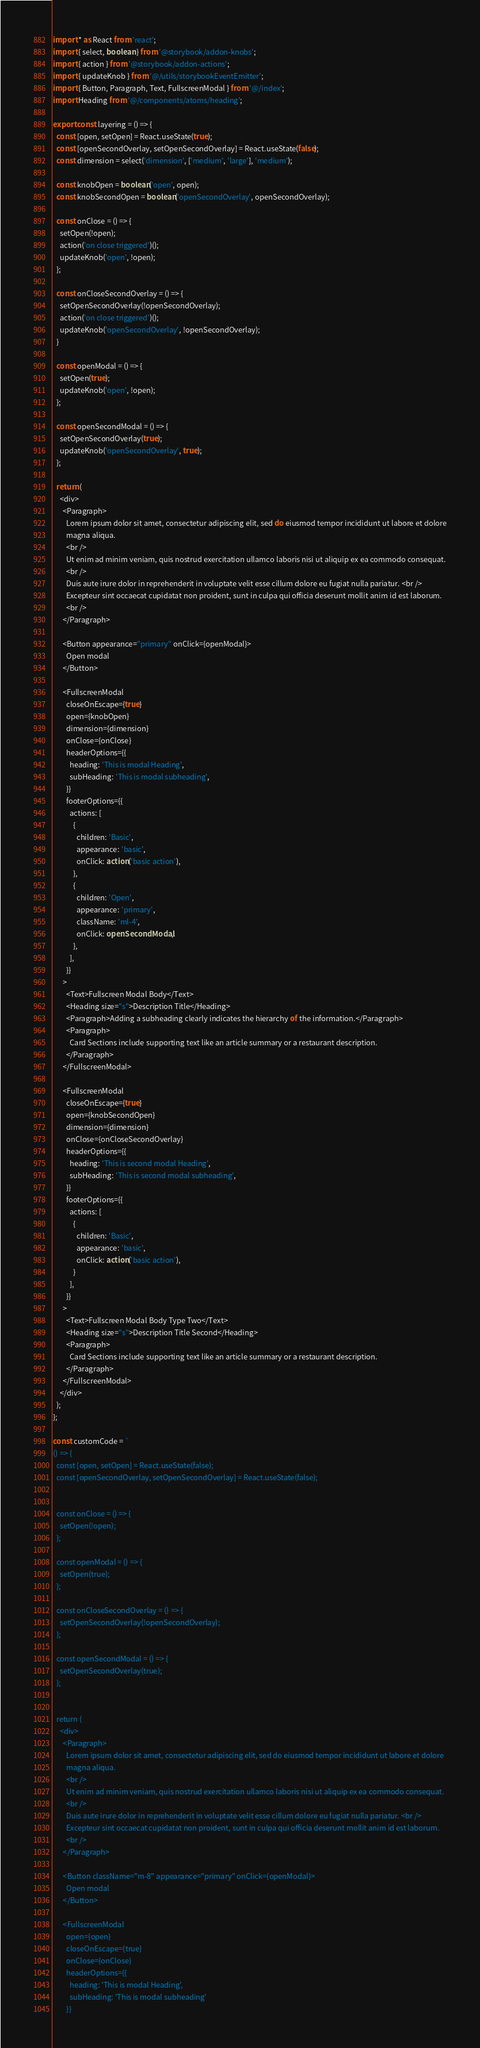Convert code to text. <code><loc_0><loc_0><loc_500><loc_500><_TypeScript_>import * as React from 'react';
import { select, boolean } from '@storybook/addon-knobs';
import { action } from '@storybook/addon-actions';
import { updateKnob } from '@/utils/storybookEventEmitter';
import { Button, Paragraph, Text, FullscreenModal } from '@/index';
import Heading from '@/components/atoms/heading';

export const layering = () => {
  const [open, setOpen] = React.useState(true);
  const [openSecondOverlay, setOpenSecondOverlay] = React.useState(false);
  const dimension = select('dimension', ['medium', 'large'], 'medium');

  const knobOpen = boolean('open', open);
  const knobSecondOpen = boolean('openSecondOverlay', openSecondOverlay);

  const onClose = () => {
    setOpen(!open);
    action('on close triggered')();
    updateKnob('open', !open);
  };

  const onCloseSecondOverlay = () => {
    setOpenSecondOverlay(!openSecondOverlay);
    action('on close triggered')();
    updateKnob('openSecondOverlay', !openSecondOverlay);
  }

  const openModal = () => {
    setOpen(true);
    updateKnob('open', !open);
  };

  const openSecondModal = () => {
    setOpenSecondOverlay(true);
    updateKnob('openSecondOverlay', true);
  };

  return (
    <div>
      <Paragraph>
        Lorem ipsum dolor sit amet, consectetur adipiscing elit, sed do eiusmod tempor incididunt ut labore et dolore
        magna aliqua.
        <br />
        Ut enim ad minim veniam, quis nostrud exercitation ullamco laboris nisi ut aliquip ex ea commodo consequat.
        <br />
        Duis aute irure dolor in reprehenderit in voluptate velit esse cillum dolore eu fugiat nulla pariatur. <br />
        Excepteur sint occaecat cupidatat non proident, sunt in culpa qui officia deserunt mollit anim id est laborum.
        <br />
      </Paragraph>

      <Button appearance="primary" onClick={openModal}>
        Open modal
      </Button>

      <FullscreenModal
        closeOnEscape={true}
        open={knobOpen}
        dimension={dimension}
        onClose={onClose}
        headerOptions={{
          heading: 'This is modal Heading',
          subHeading: 'This is modal subheading',
        }}
        footerOptions={{
          actions: [
            {
              children: 'Basic',
              appearance: 'basic',
              onClick: action('basic action'),
            },
            {
              children: 'Open',
              appearance: 'primary',
              className: 'ml-4',
              onClick: openSecondModal,
            },
          ],
        }}
      >
        <Text>Fullscreen Modal Body</Text>
        <Heading size="s">Description Title</Heading>
        <Paragraph>Adding a subheading clearly indicates the hierarchy of the information.</Paragraph>
        <Paragraph>
          Card Sections include supporting text like an article summary or a restaurant description.
        </Paragraph>
      </FullscreenModal>

      <FullscreenModal
        closeOnEscape={true}
        open={knobSecondOpen}
        dimension={dimension}
        onClose={onCloseSecondOverlay}
        headerOptions={{
          heading: 'This is second modal Heading',
          subHeading: 'This is second modal subheading',
        }}
        footerOptions={{
          actions: [
            {
              children: 'Basic',
              appearance: 'basic',
              onClick: action('basic action'),
            }
          ],
        }}
      >
        <Text>Fullscreen Modal Body Type Two</Text>
        <Heading size="s">Description Title Second</Heading>
        <Paragraph>
          Card Sections include supporting text like an article summary or a restaurant description.
        </Paragraph>
      </FullscreenModal>
    </div>
  );
};

const customCode = `
() => {
  const [open, setOpen] = React.useState(false);
  const [openSecondOverlay, setOpenSecondOverlay] = React.useState(false);


  const onClose = () => {
    setOpen(!open);
  };

  const openModal = () => {
    setOpen(true);
  };

  const onCloseSecondOverlay = () => {
    setOpenSecondOverlay(!openSecondOverlay);
  };

  const openSecondModal = () => {
    setOpenSecondOverlay(true);
  };


  return (
    <div>
      <Paragraph>
        Lorem ipsum dolor sit amet, consectetur adipiscing elit, sed do eiusmod tempor incididunt ut labore et dolore
        magna aliqua.
        <br />
        Ut enim ad minim veniam, quis nostrud exercitation ullamco laboris nisi ut aliquip ex ea commodo consequat.
        <br />
        Duis aute irure dolor in reprehenderit in voluptate velit esse cillum dolore eu fugiat nulla pariatur. <br />
        Excepteur sint occaecat cupidatat non proident, sunt in culpa qui officia deserunt mollit anim id est laborum.
        <br />
      </Paragraph>

      <Button className="m-8" appearance="primary" onClick={openModal}>
        Open modal
      </Button>

      <FullscreenModal
        open={open}
        closeOnEscape={true}
        onClose={onClose}
        headerOptions={{
          heading: 'This is modal Heading',
          subHeading: 'This is modal subheading'
        }}</code> 